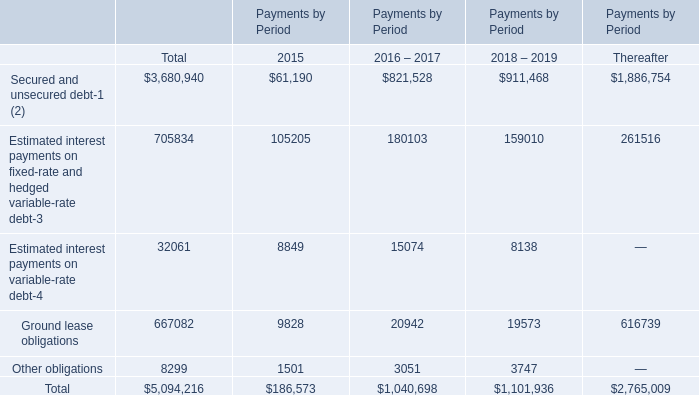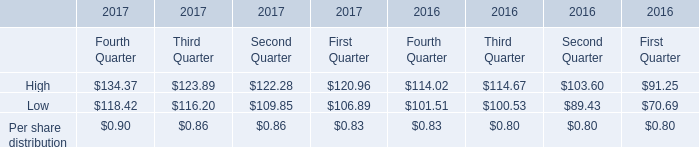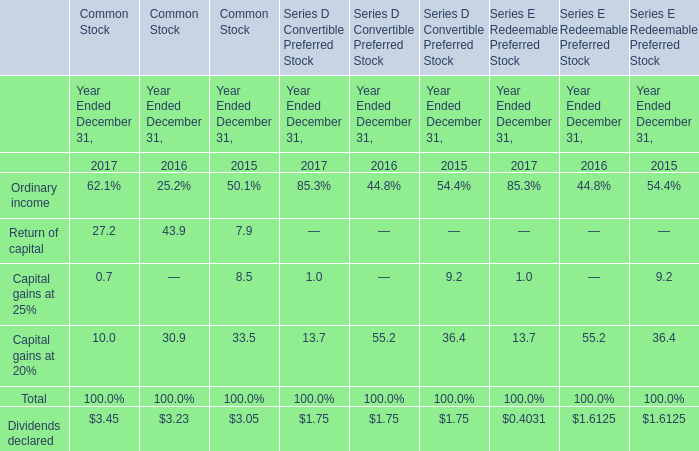Which year is Per share distribution the lowest? (in year) 
Answer: 2016. 